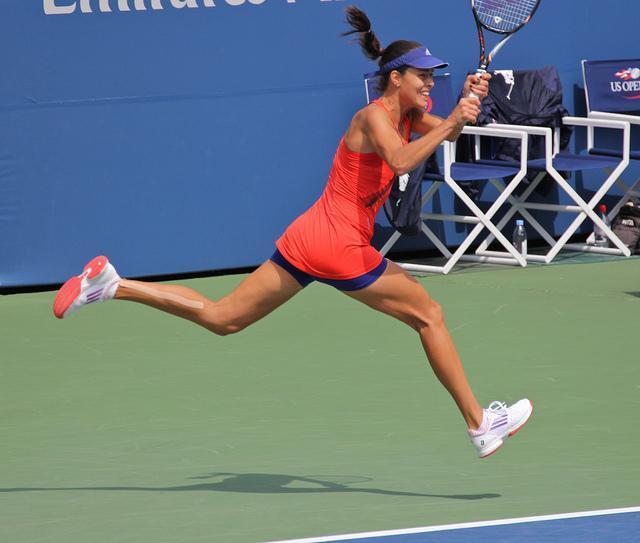How many chairs are visible?
Give a very brief answer. 3. 